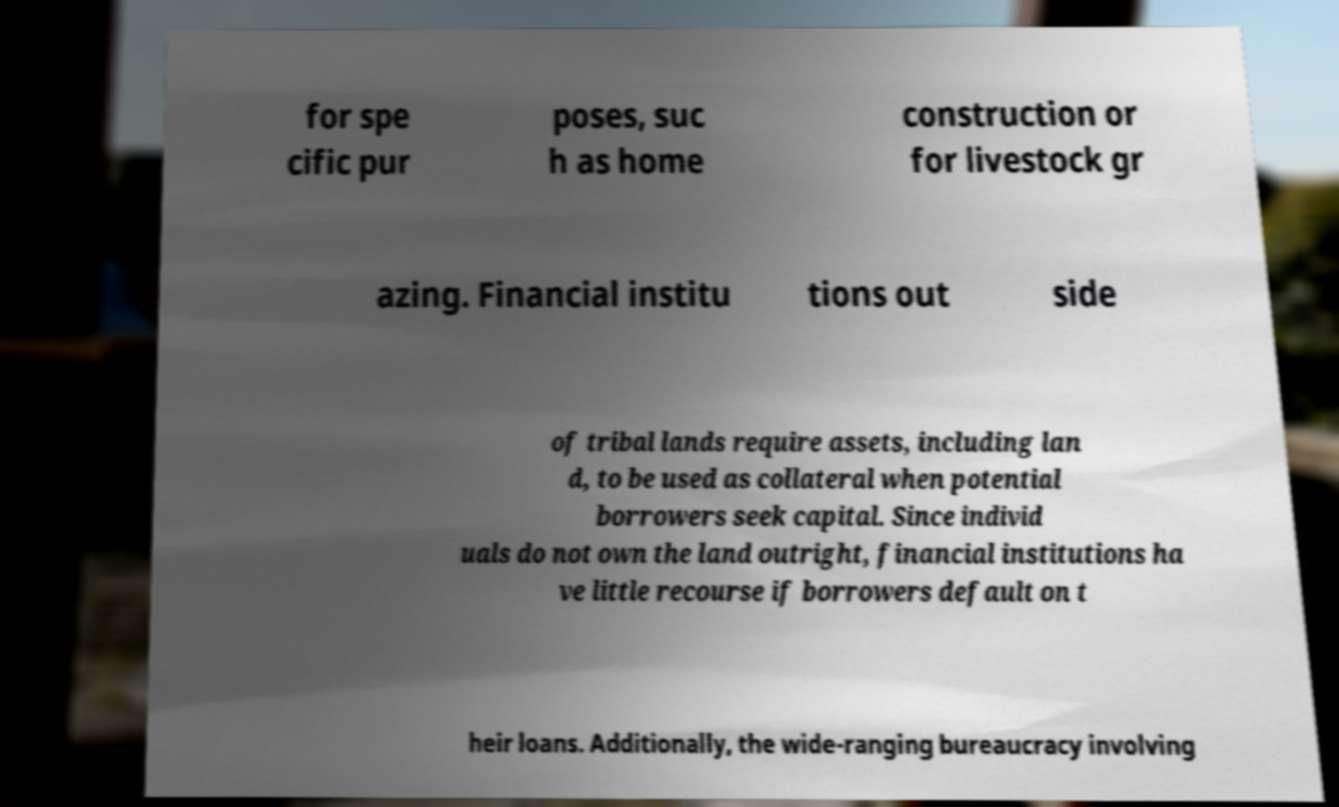For documentation purposes, I need the text within this image transcribed. Could you provide that? for spe cific pur poses, suc h as home construction or for livestock gr azing. Financial institu tions out side of tribal lands require assets, including lan d, to be used as collateral when potential borrowers seek capital. Since individ uals do not own the land outright, financial institutions ha ve little recourse if borrowers default on t heir loans. Additionally, the wide-ranging bureaucracy involving 